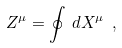Convert formula to latex. <formula><loc_0><loc_0><loc_500><loc_500>Z ^ { \mu } = \oint \, d X ^ { \mu } \ ,</formula> 